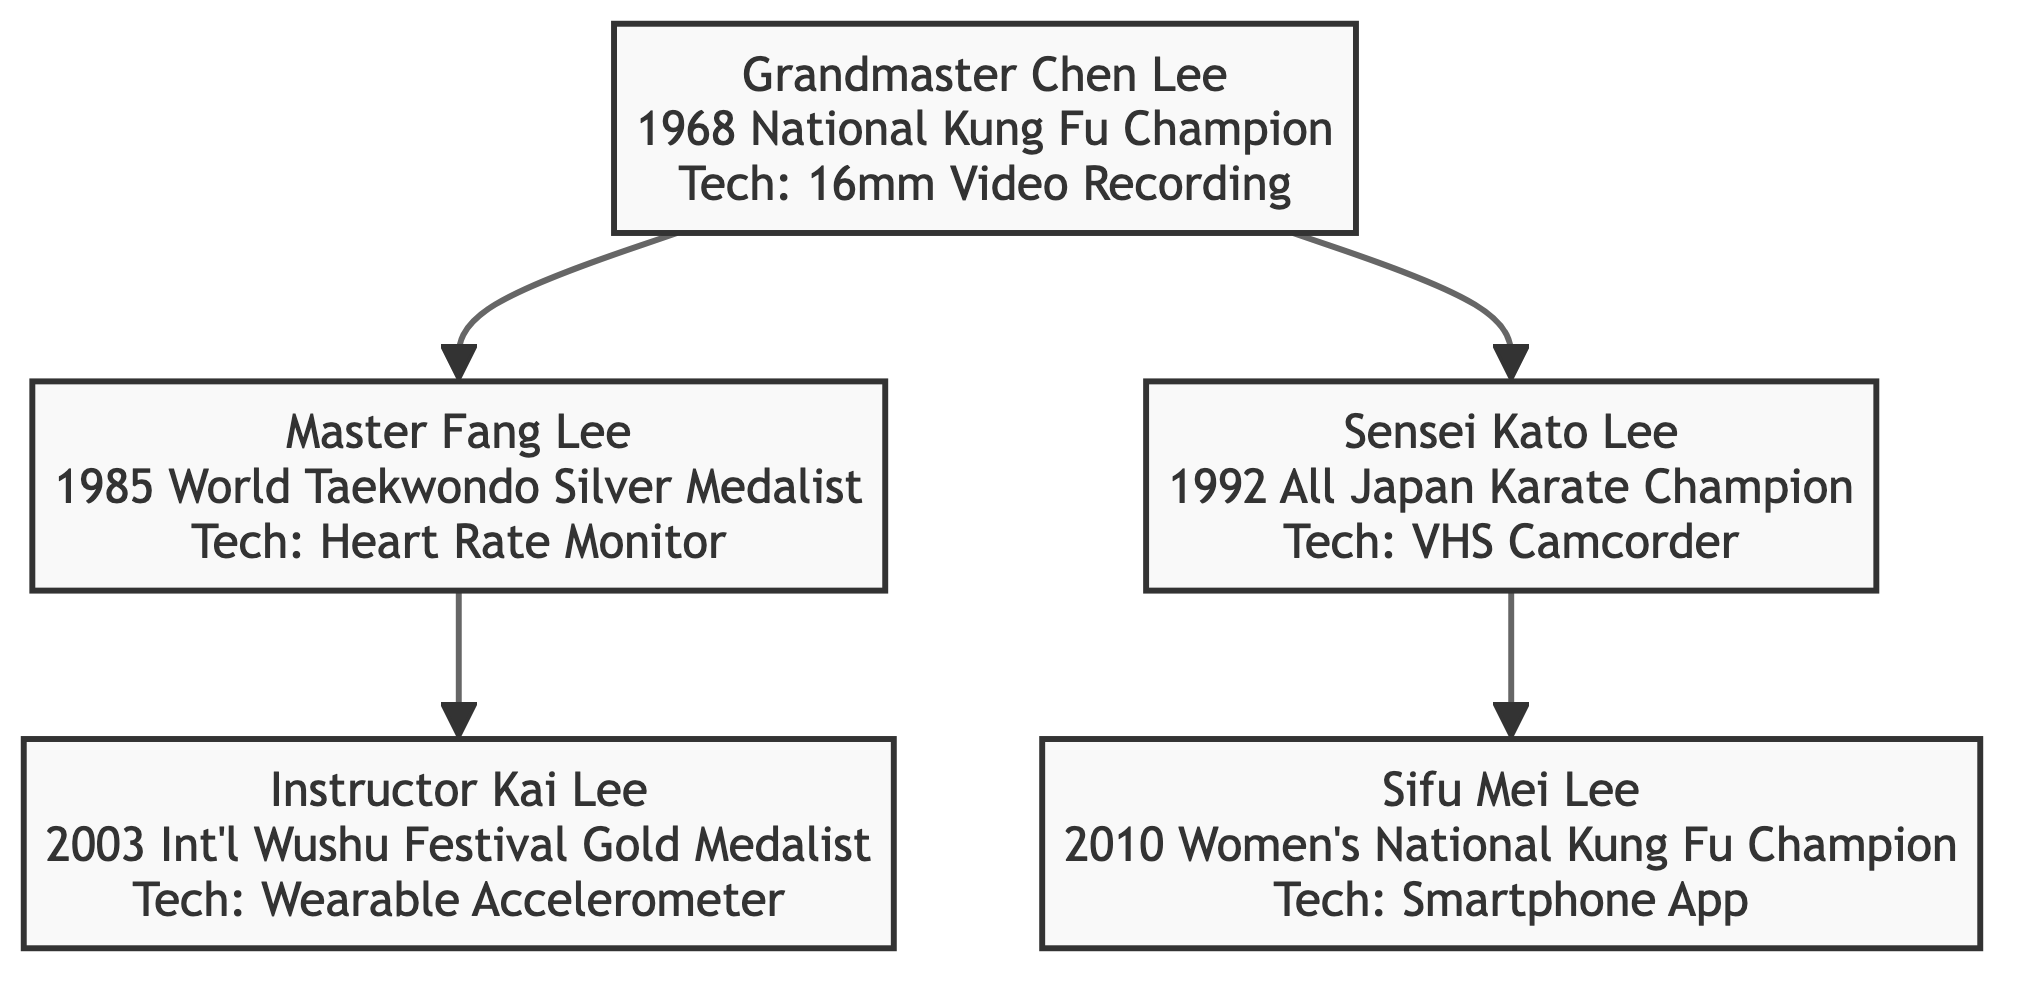What title did Grandmaster Chen Lee achieve? The diagram indicates that Grandmaster Chen Lee achieved the title of Champion at the 1968 National Kung Fu Championship.
Answer: Champion Which technology did Sensei Kato Lee use for her training? According to the diagram, Sensei Kato Lee used a Mitsubishi VHS Camcorder to review her sparring sessions.
Answer: Mitsubishi VHS Camcorder How many generations of martial artists are represented in the family tree? The diagram shows three generations: Grandmaster Chen Lee (1st generation), his children Master Fang Lee and Sensei Kato Lee (2nd generation), and their children Instructor Kai Lee and Sifu Mei Lee (3rd generation).
Answer: Three What achievement did Instructor Kai Lee obtain? The diagram reveals that Instructor Kai Lee won a Gold Medal at the 2003 International Wushu Festival.
Answer: Gold Medal Which family member is associated with a Smartphone App? According to the diagram, Sifu Mei Lee is associated with using a Smartphone App for training schedule and diet management.
Answer: Sifu Mei Lee What relationship does Master Fang Lee have with Grandmaster Chen Lee? The diagram indicates that Master Fang Lee is the son of Grandmaster Chen Lee.
Answer: Son Which competition did Sifu Mei Lee compete in? The diagram presents that Sifu Mei Lee competed in the 2010 Women’s National Kung Fu Championship.
Answer: 2010 Women’s National Kung Fu Championship Which technology was utilized by Master Fang Lee during his training? The diagram states that Master Fang Lee used a Heart Rate Monitor for optimized training during his preparation.
Answer: Heart Rate Monitor What is the connection between Instructor Kai Lee and Master Fang Lee? The diagram illustrates that Instructor Kai Lee is the grandson of Master Fang Lee, specifically the son of Master Fang Lee.
Answer: Grandson 